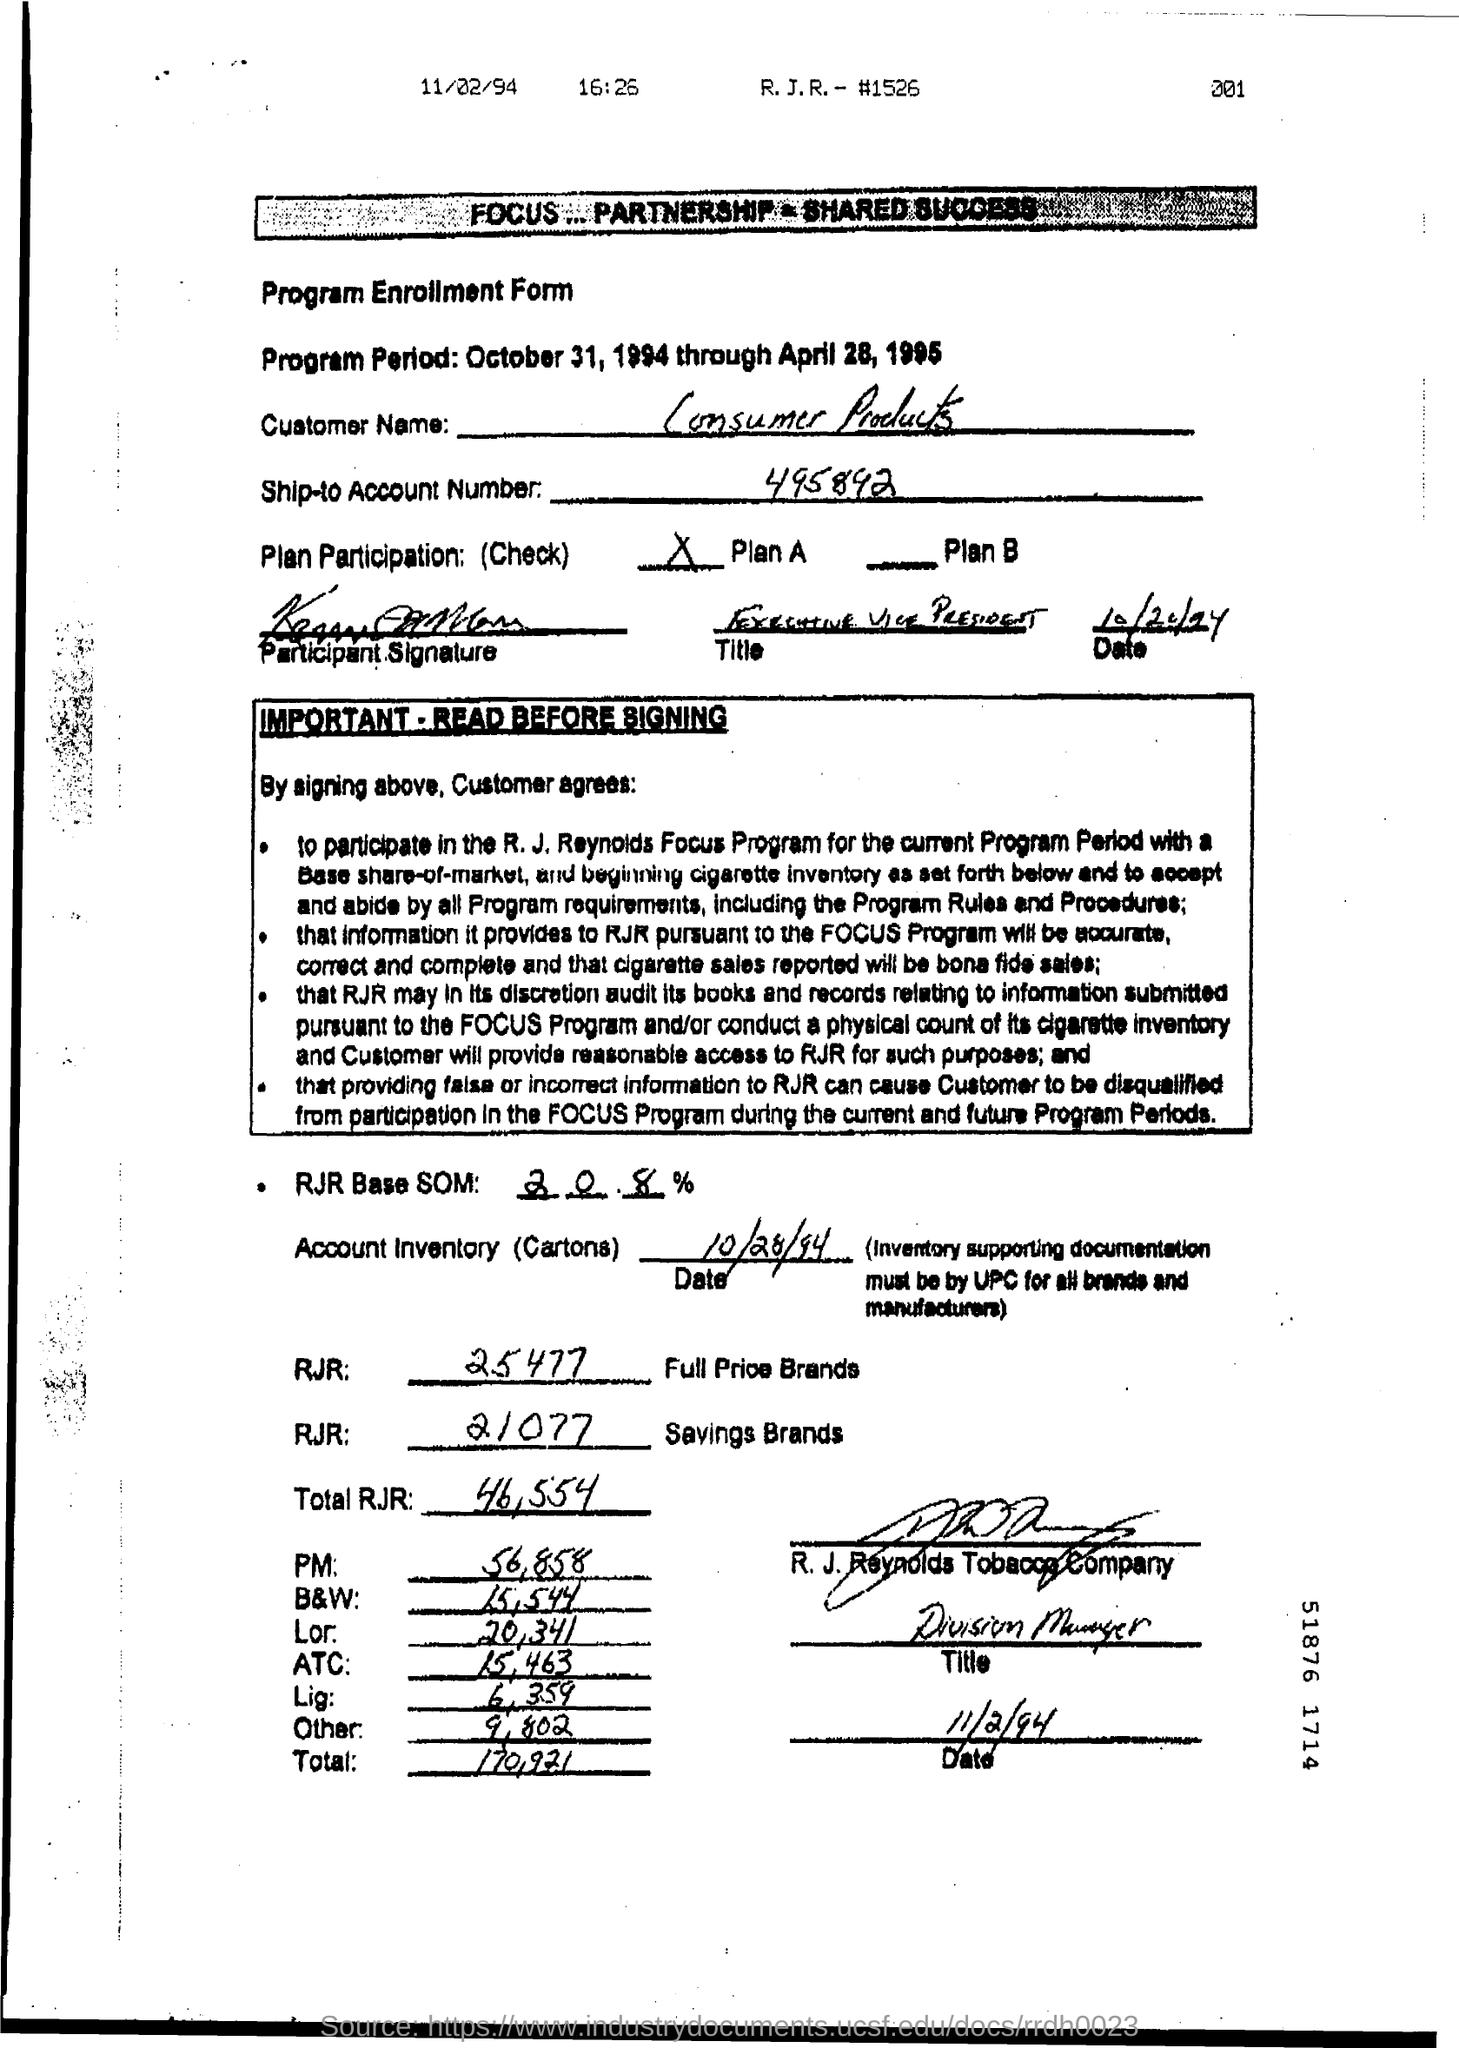What is Ship-to Account Number ? The Ship-to Account Number, as shown in the image of the document, appears to be '495892'. This number is used to identify the customer's account for shipping purposes in the context of the Program Enrollment Form. 